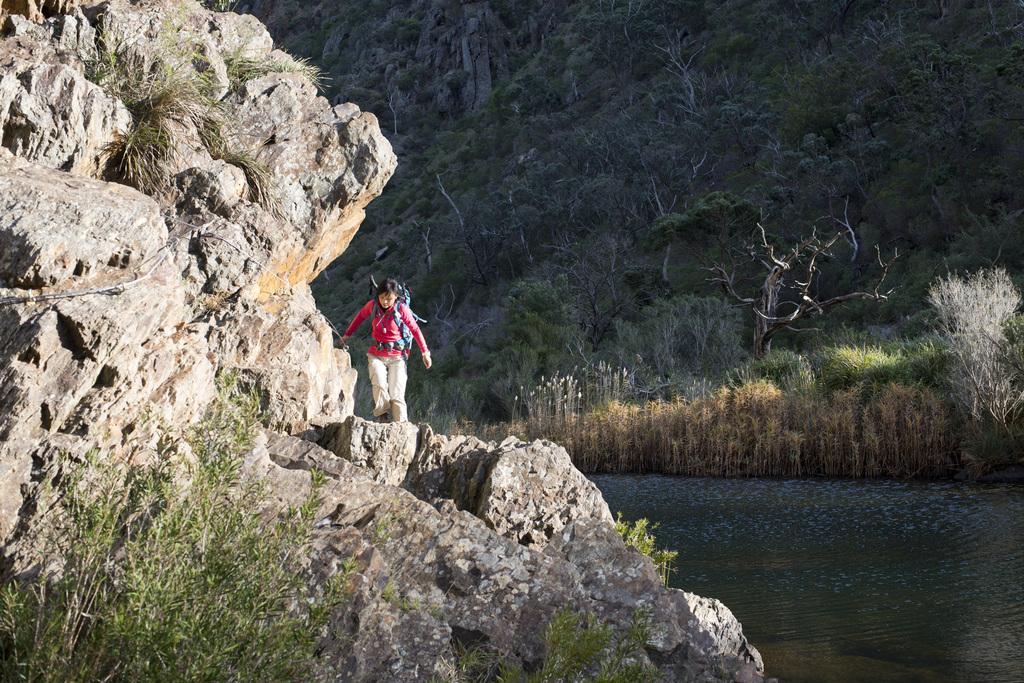In one or two sentences, can you explain what this image depicts? In this picture we can see plants, rocks, person carrying a bag, water and in the background we can see trees. 